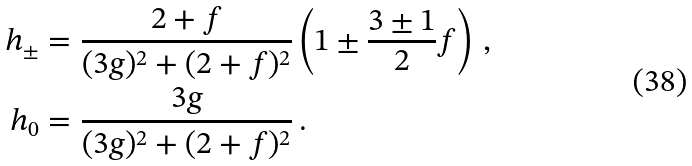Convert formula to latex. <formula><loc_0><loc_0><loc_500><loc_500>h _ { \pm } & = \frac { 2 + f } { ( 3 g ) ^ { 2 } + ( 2 + f ) ^ { 2 } } \left ( 1 \pm \frac { 3 \pm 1 } { 2 } f \right ) \, , \\ h _ { 0 } & = \frac { 3 g } { ( 3 g ) ^ { 2 } + ( 2 + f ) ^ { 2 } } \, .</formula> 